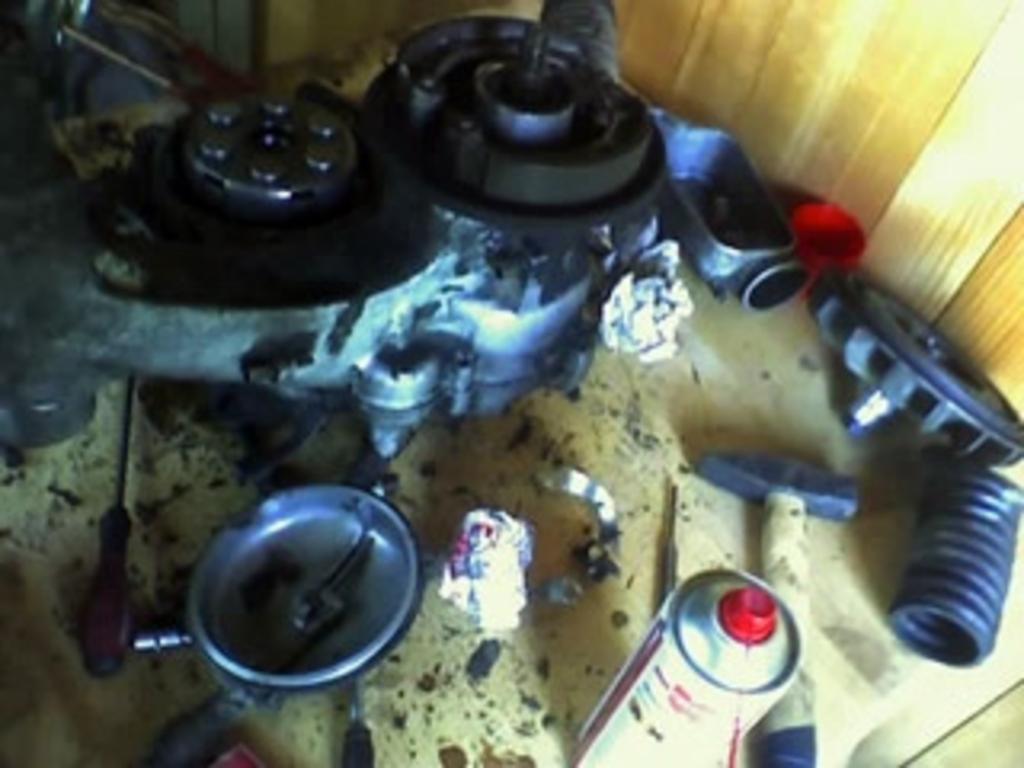Describe this image in one or two sentences. In this picture we can see a screwdriver, hammer and some objects. At the top right corner of the image, it looks like a wooden wall. 